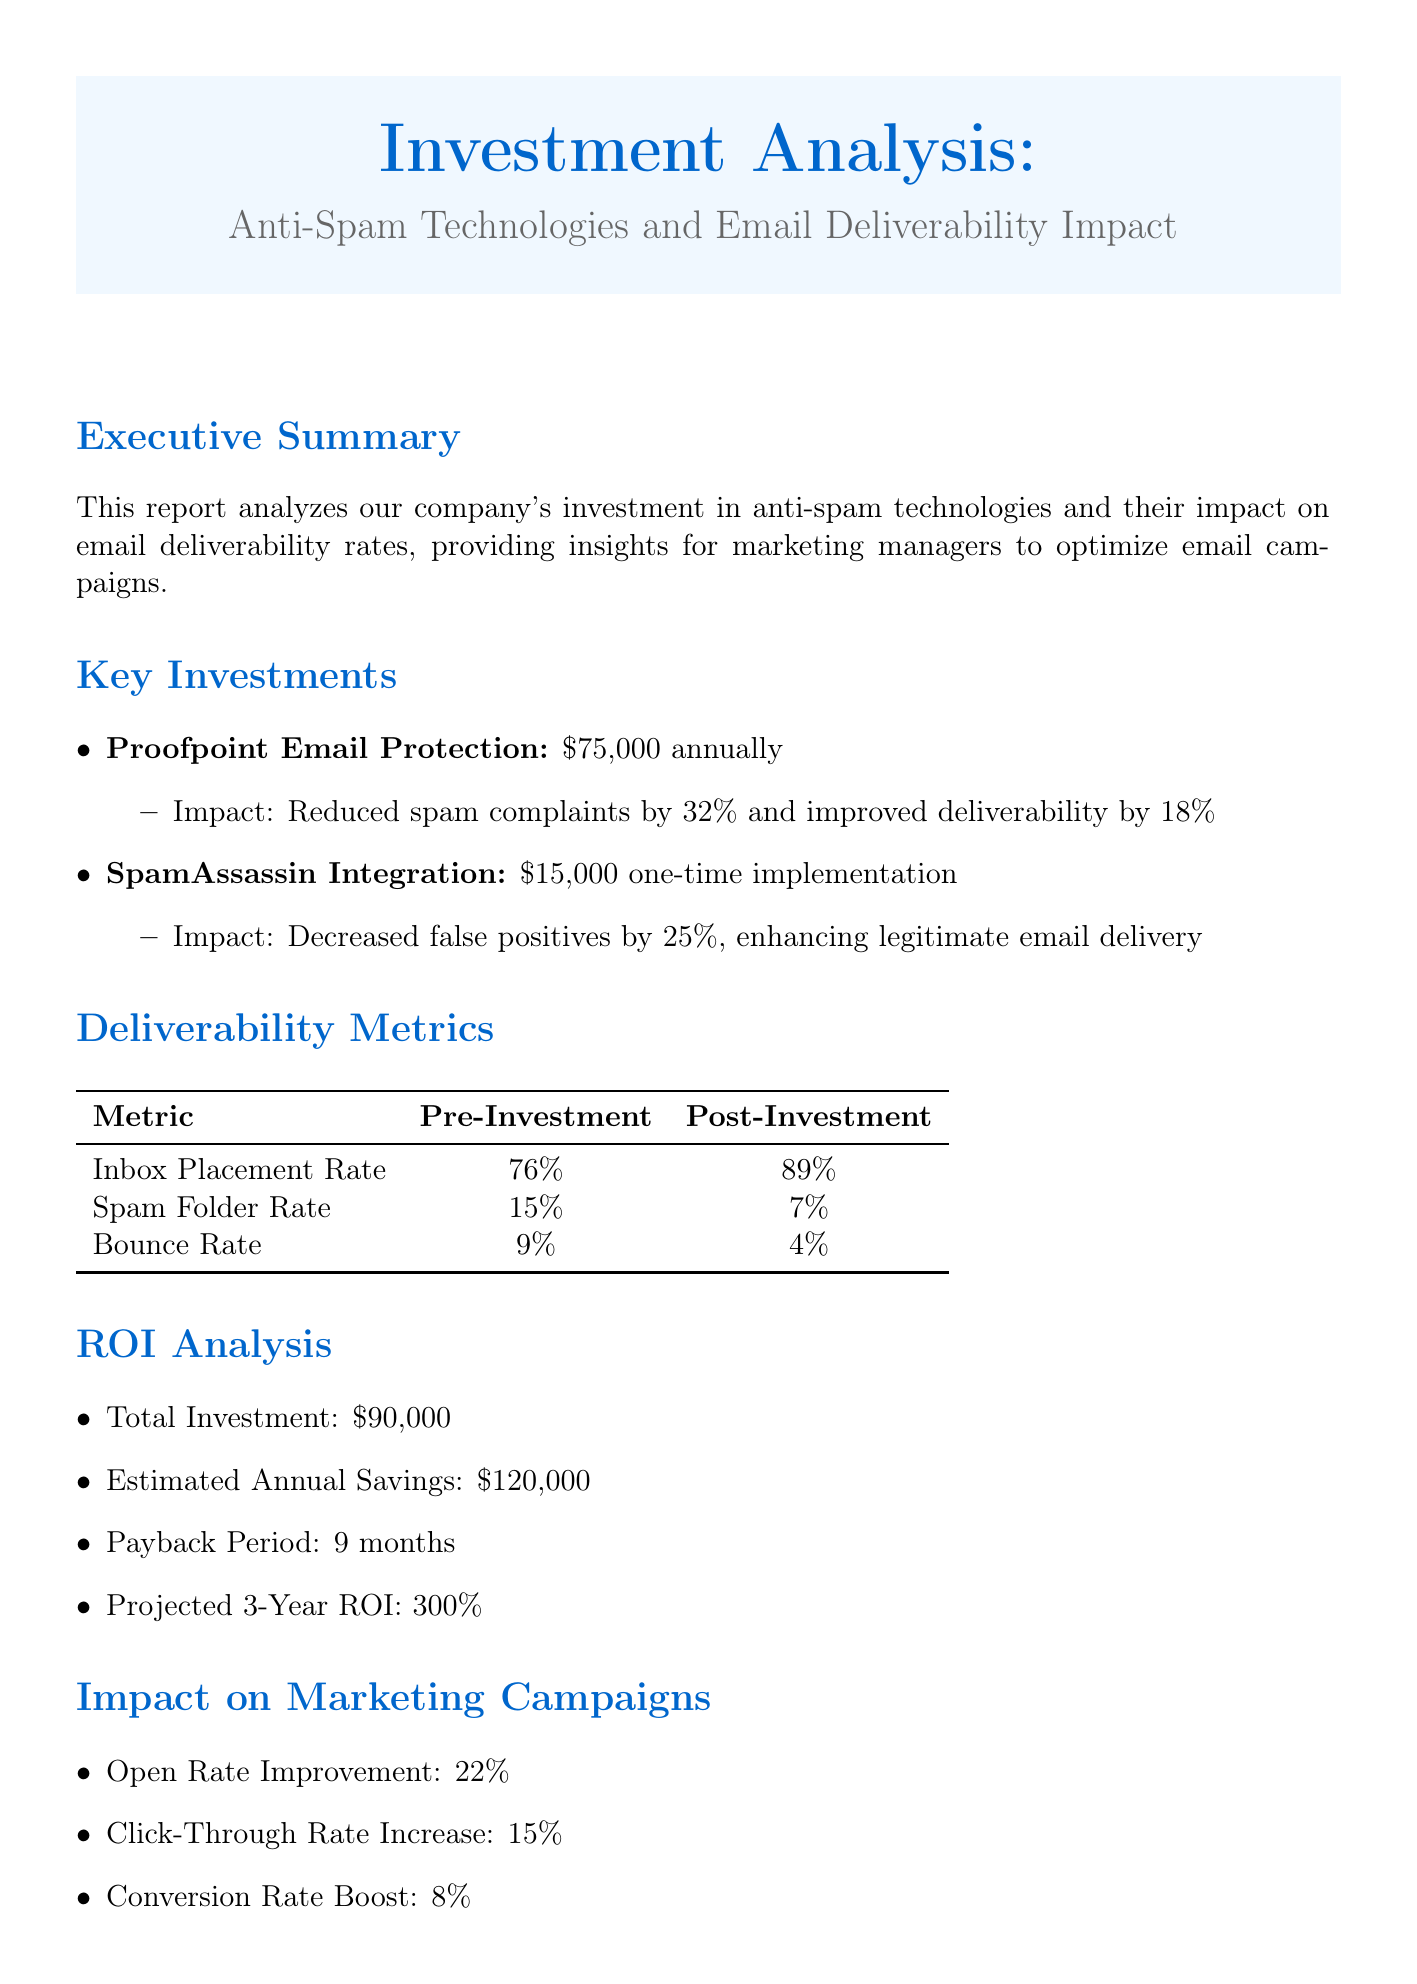What is the title of the report? The title of the report is explicitly stated at the beginning.
Answer: Investment Analysis: Anti-Spam Technologies and Email Deliverability Impact What is the annual cost of Proofpoint Email Protection? The report lists the cost associated with this technology under key investments.
Answer: $75,000 annually What was the inbox placement rate before the investment? The pre-investment metrics can be found in the deliverability metrics section.
Answer: 76% What is the percentage decrease in spam folder rate after the investment? The document provides the post-investment and pre-investment spam folder rates for comparison.
Answer: 8% What is the payback period for the total investment? The payback period is listed in the ROI analysis section of the report.
Answer: 9 months What improvement is seen in the open rate after implementing the technologies? The impact on marketing campaigns section outlines the improvements in key metrics.
Answer: 22% What is the total investment made in anti-spam technologies? This information can be found in the ROI analysis section of the report.
Answer: $90,000 What recommendation is made regarding staff training? The recommendations section specifies ongoing training as a suggestion for best practices.
Answer: Implement regular staff training on email best practices What projected ROI does the report mention after three years? The report details the projected ROI as part of the financial analysis.
Answer: 300% 